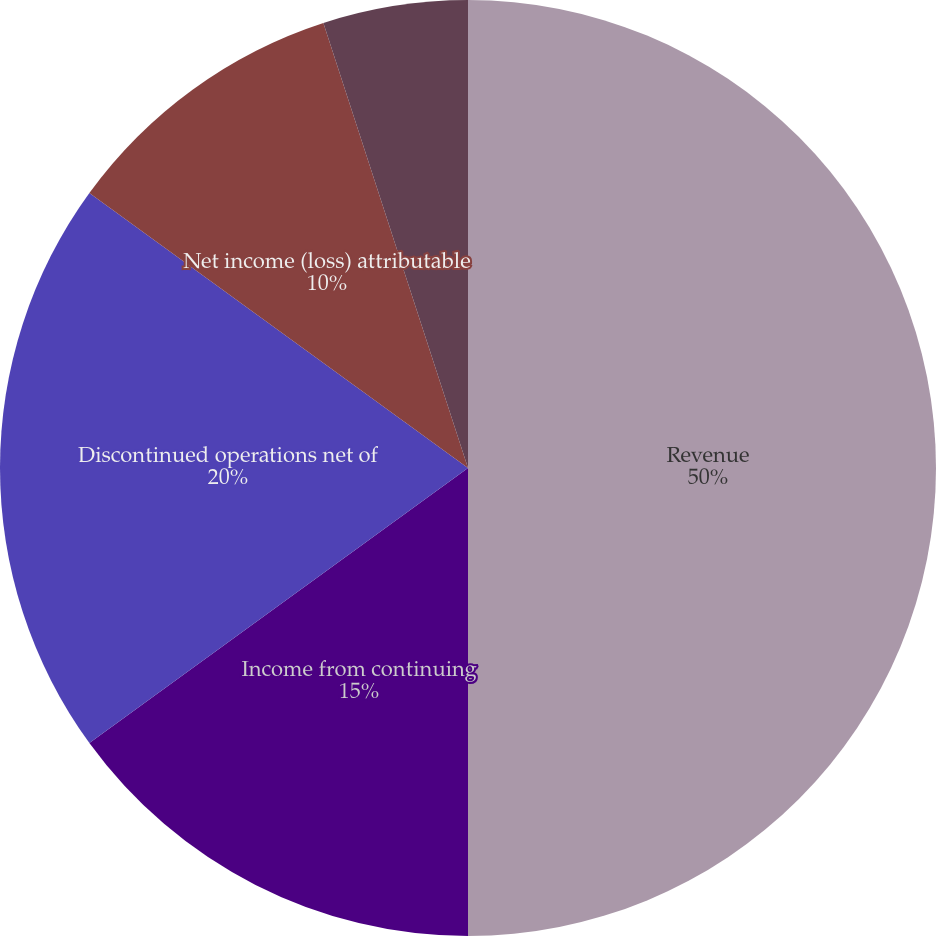Convert chart. <chart><loc_0><loc_0><loc_500><loc_500><pie_chart><fcel>Revenue<fcel>Income from continuing<fcel>Discontinued operations net of<fcel>Net income (loss) attributable<fcel>Basic earnings (loss) per<fcel>Diluted earnings (loss) per<nl><fcel>50.0%<fcel>15.0%<fcel>20.0%<fcel>10.0%<fcel>0.0%<fcel>5.0%<nl></chart> 